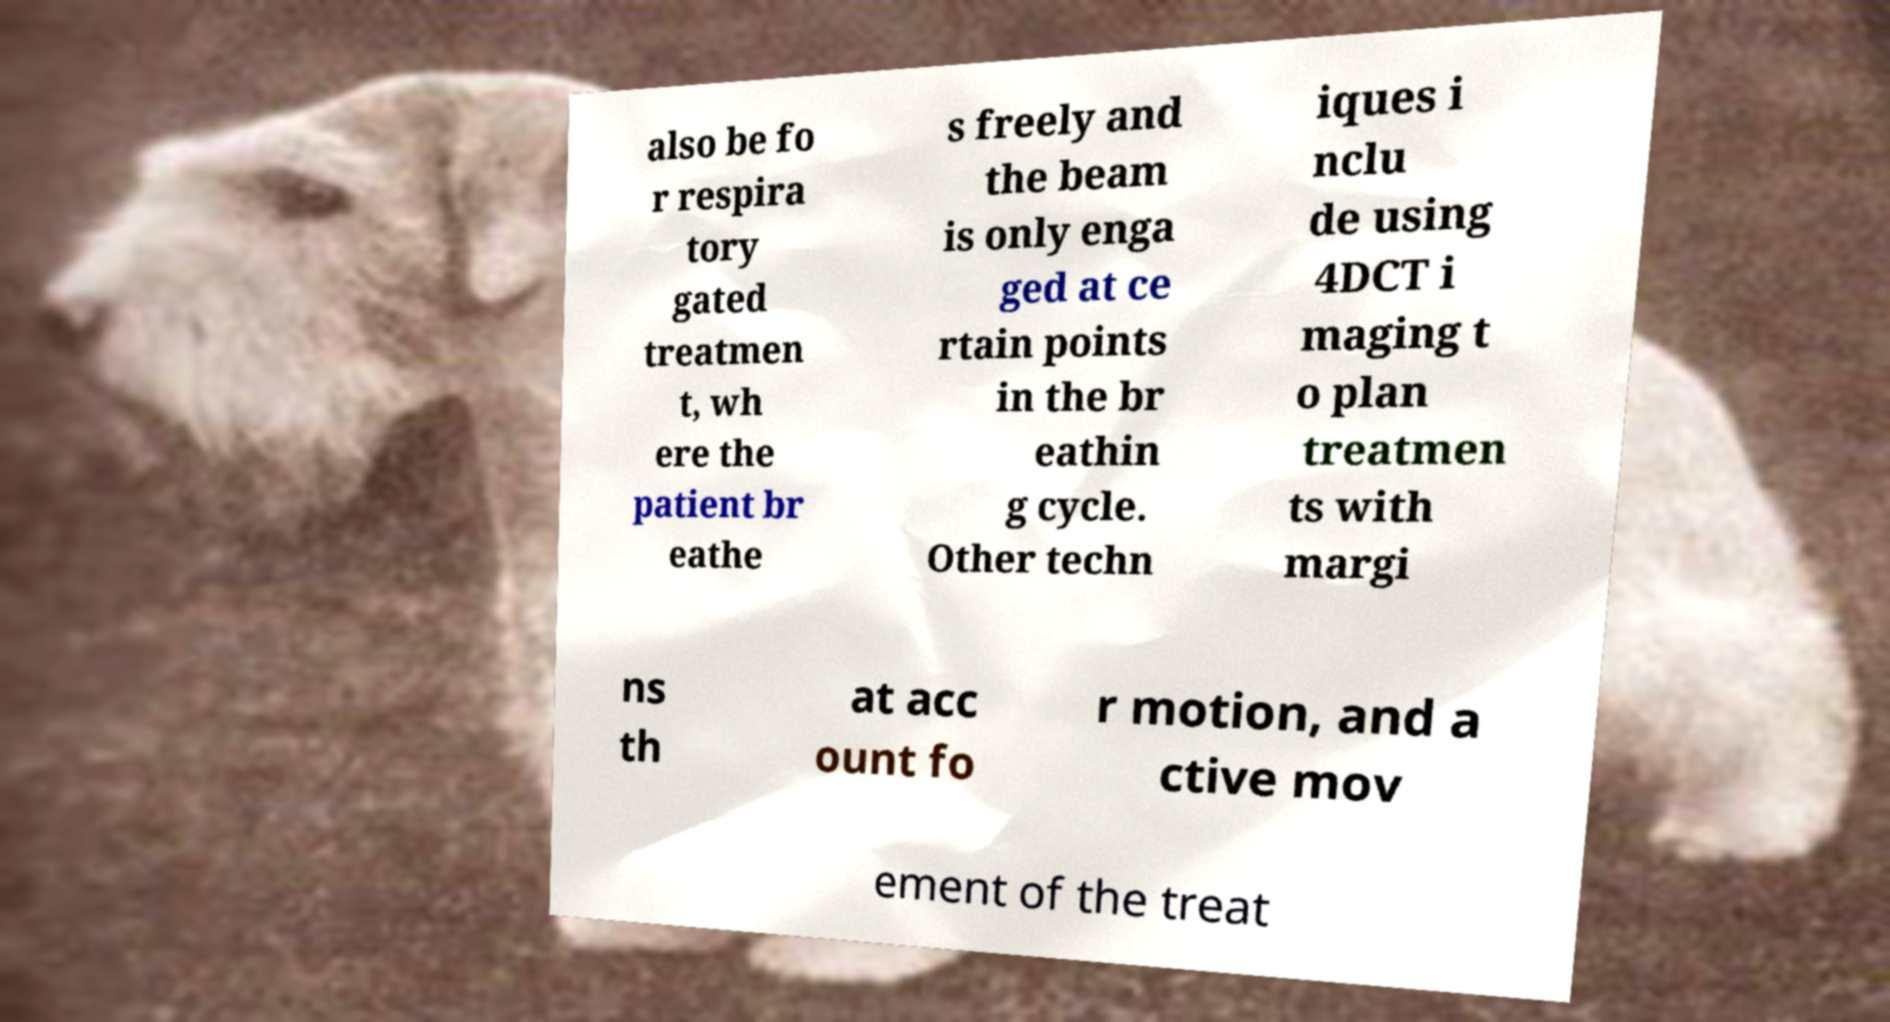Please identify and transcribe the text found in this image. also be fo r respira tory gated treatmen t, wh ere the patient br eathe s freely and the beam is only enga ged at ce rtain points in the br eathin g cycle. Other techn iques i nclu de using 4DCT i maging t o plan treatmen ts with margi ns th at acc ount fo r motion, and a ctive mov ement of the treat 